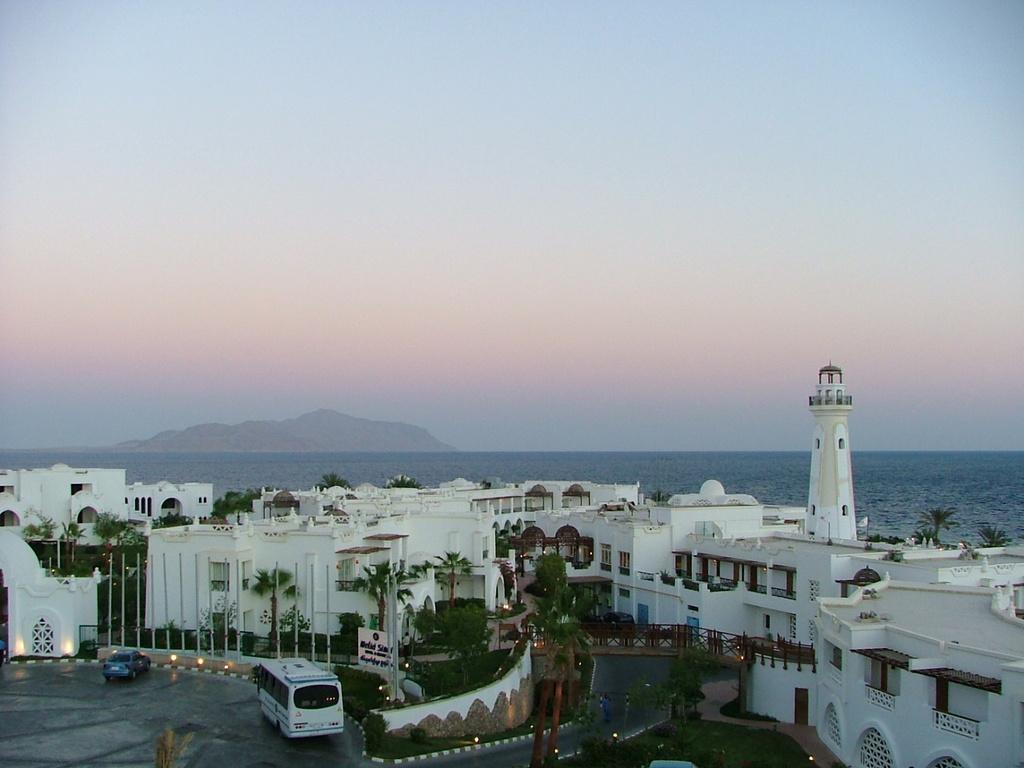Please provide a concise description of this image. In the foreground of the image we can see road, vehicles, buildings and trees. In the middle of the image we can see water body and hills. On the top of the image we can see the sky. 